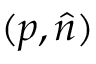<formula> <loc_0><loc_0><loc_500><loc_500>( p , { \hat { n } } )</formula> 